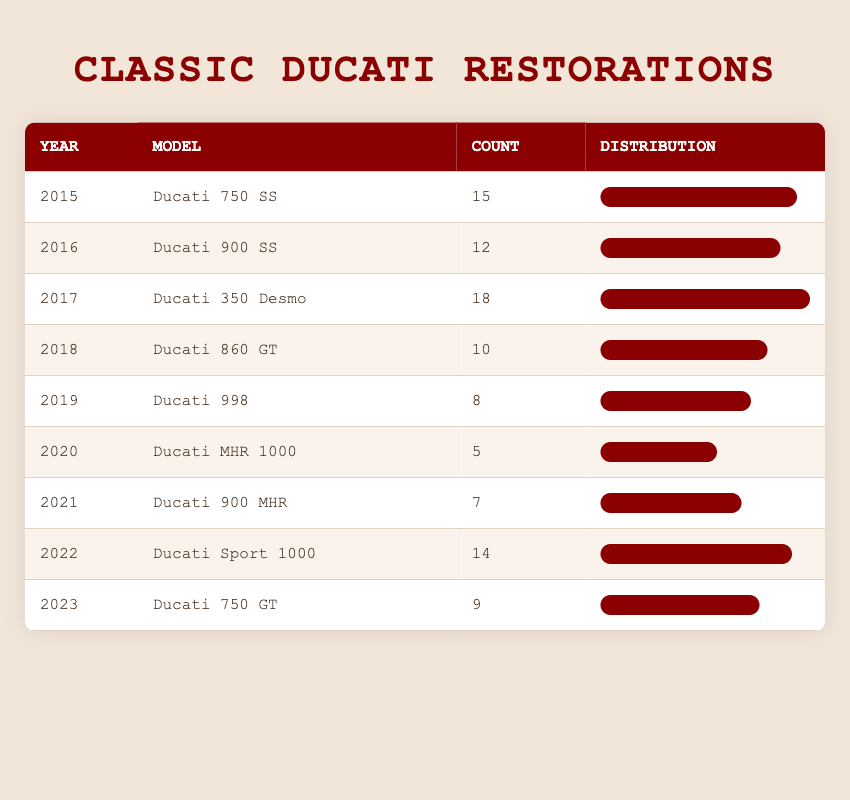What is the model restored in 2017? To find the model restored in 2017, we look for the row where the year is 2017. The model listed in that row is "Ducati 350 Desmo."
Answer: Ducati 350 Desmo How many Ducati 750 SS were restored in 2015? By checking the row for the year 2015, we see that 15 units of the "Ducati 750 SS" were restored.
Answer: 15 What was the total number of restorations from 2015 to 2021? We need to sum the counts from the years 2015 to 2021. The counts are: 15 (2015) + 12 (2016) + 18 (2017) + 10 (2018) + 8 (2019) + 5 (2020) + 7 (2021) = 75.
Answer: 75 Was there a decline in the number of restorations from 2018 to 2019? We compare the counts from each year in that range: in 2018, there were 10 restorations, and in 2019, there were 8. Since 8 is less than 10, this indicates a decline.
Answer: Yes Which year had the highest number of restorations, and how many were there? To determine the year with the highest restorations, we analyze the counts across all years. The highest count is 18 restorations in 2017 for the model "Ducati 350 Desmo."
Answer: 2017, 18 